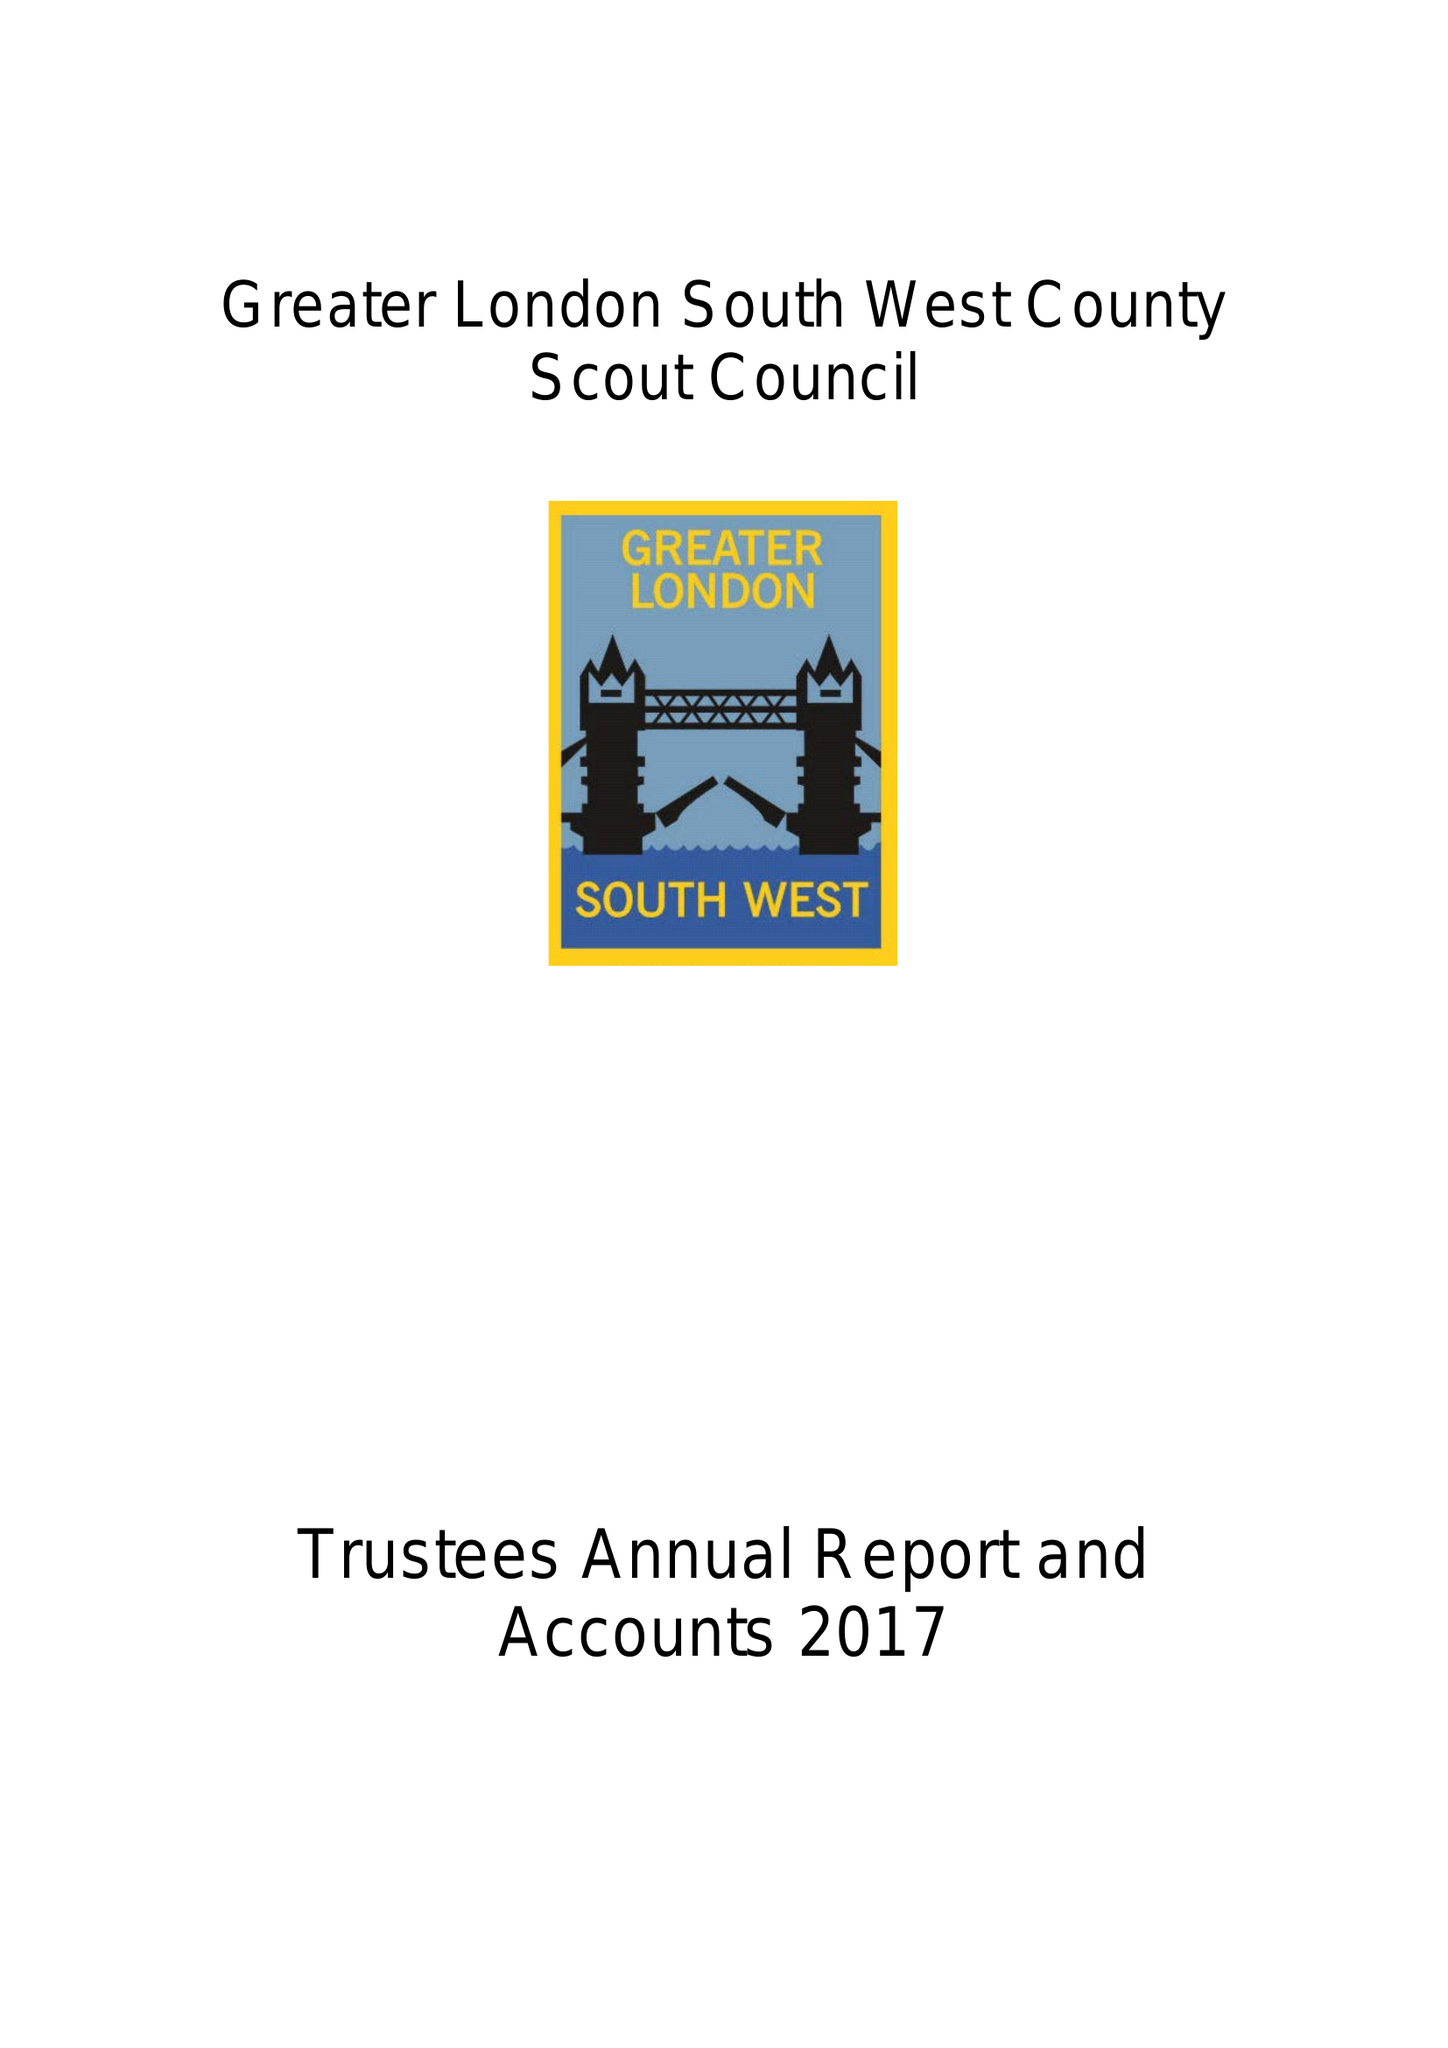What is the value for the charity_number?
Answer the question using a single word or phrase. 303884 